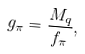<formula> <loc_0><loc_0><loc_500><loc_500>g _ { \pi } = \frac { M _ { q } } { f _ { \pi } } ,</formula> 